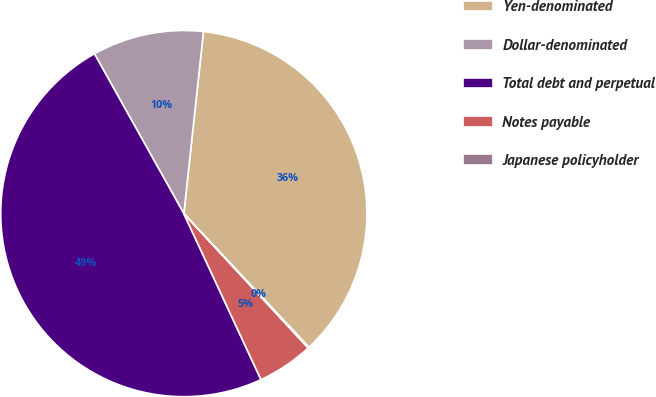<chart> <loc_0><loc_0><loc_500><loc_500><pie_chart><fcel>Yen-denominated<fcel>Dollar-denominated<fcel>Total debt and perpetual<fcel>Notes payable<fcel>Japanese policyholder<nl><fcel>36.31%<fcel>9.83%<fcel>48.8%<fcel>4.96%<fcel>0.09%<nl></chart> 